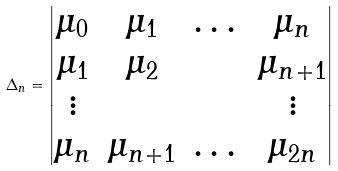Convert formula to latex. <formula><loc_0><loc_0><loc_500><loc_500>\Delta _ { n } = \begin{vmatrix} \mu _ { 0 } & \mu _ { 1 } & \dots & \mu _ { n } \\ \mu _ { 1 } & \mu _ { 2 } & & \mu _ { n + 1 } \\ \vdots & & & \vdots \\ \mu _ { n } & \mu _ { n + 1 } & \dots & \mu _ { 2 n } \end{vmatrix}</formula> 